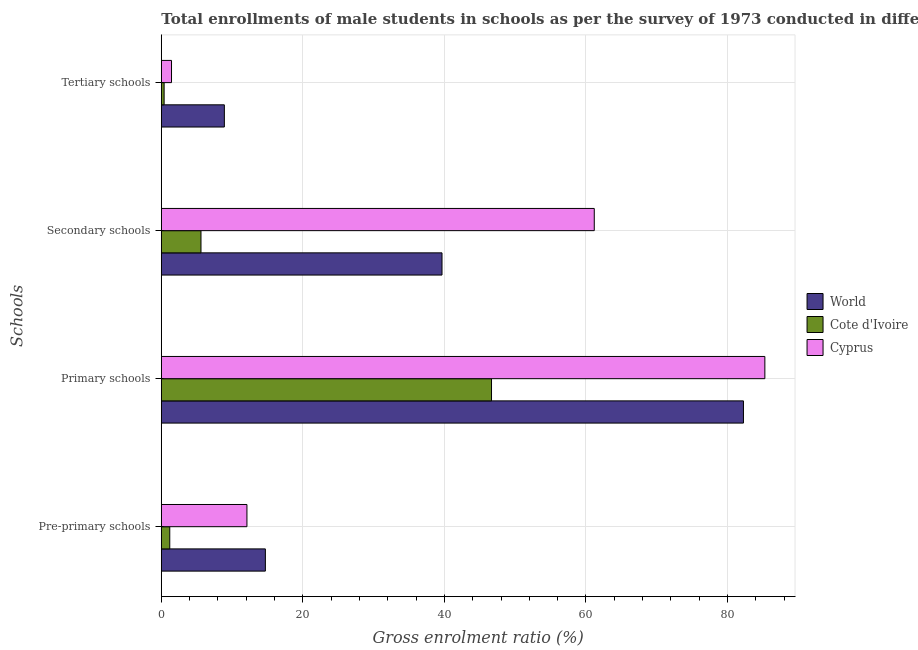Are the number of bars on each tick of the Y-axis equal?
Offer a terse response. Yes. What is the label of the 3rd group of bars from the top?
Your answer should be compact. Primary schools. What is the gross enrolment ratio(male) in pre-primary schools in World?
Ensure brevity in your answer.  14.7. Across all countries, what is the maximum gross enrolment ratio(male) in secondary schools?
Ensure brevity in your answer.  61.18. Across all countries, what is the minimum gross enrolment ratio(male) in tertiary schools?
Provide a succinct answer. 0.4. In which country was the gross enrolment ratio(male) in primary schools maximum?
Keep it short and to the point. Cyprus. In which country was the gross enrolment ratio(male) in pre-primary schools minimum?
Give a very brief answer. Cote d'Ivoire. What is the total gross enrolment ratio(male) in pre-primary schools in the graph?
Make the answer very short. 28. What is the difference between the gross enrolment ratio(male) in pre-primary schools in Cyprus and that in Cote d'Ivoire?
Give a very brief answer. 10.91. What is the difference between the gross enrolment ratio(male) in secondary schools in Cyprus and the gross enrolment ratio(male) in tertiary schools in World?
Your response must be concise. 52.27. What is the average gross enrolment ratio(male) in tertiary schools per country?
Your answer should be very brief. 3.58. What is the difference between the gross enrolment ratio(male) in secondary schools and gross enrolment ratio(male) in tertiary schools in World?
Offer a terse response. 30.76. In how many countries, is the gross enrolment ratio(male) in pre-primary schools greater than 8 %?
Provide a short and direct response. 2. What is the ratio of the gross enrolment ratio(male) in secondary schools in World to that in Cote d'Ivoire?
Ensure brevity in your answer.  7.08. Is the difference between the gross enrolment ratio(male) in pre-primary schools in Cote d'Ivoire and Cyprus greater than the difference between the gross enrolment ratio(male) in primary schools in Cote d'Ivoire and Cyprus?
Provide a succinct answer. Yes. What is the difference between the highest and the second highest gross enrolment ratio(male) in tertiary schools?
Make the answer very short. 7.47. What is the difference between the highest and the lowest gross enrolment ratio(male) in tertiary schools?
Offer a very short reply. 8.51. In how many countries, is the gross enrolment ratio(male) in secondary schools greater than the average gross enrolment ratio(male) in secondary schools taken over all countries?
Your answer should be very brief. 2. Is it the case that in every country, the sum of the gross enrolment ratio(male) in pre-primary schools and gross enrolment ratio(male) in secondary schools is greater than the sum of gross enrolment ratio(male) in primary schools and gross enrolment ratio(male) in tertiary schools?
Give a very brief answer. No. What does the 2nd bar from the top in Primary schools represents?
Offer a very short reply. Cote d'Ivoire. What does the 3rd bar from the bottom in Primary schools represents?
Provide a succinct answer. Cyprus. How many countries are there in the graph?
Ensure brevity in your answer.  3. How are the legend labels stacked?
Give a very brief answer. Vertical. What is the title of the graph?
Ensure brevity in your answer.  Total enrollments of male students in schools as per the survey of 1973 conducted in different countries. What is the label or title of the X-axis?
Provide a short and direct response. Gross enrolment ratio (%). What is the label or title of the Y-axis?
Ensure brevity in your answer.  Schools. What is the Gross enrolment ratio (%) of World in Pre-primary schools?
Keep it short and to the point. 14.7. What is the Gross enrolment ratio (%) in Cote d'Ivoire in Pre-primary schools?
Keep it short and to the point. 1.19. What is the Gross enrolment ratio (%) in Cyprus in Pre-primary schools?
Give a very brief answer. 12.1. What is the Gross enrolment ratio (%) in World in Primary schools?
Offer a terse response. 82.26. What is the Gross enrolment ratio (%) in Cote d'Ivoire in Primary schools?
Make the answer very short. 46.66. What is the Gross enrolment ratio (%) in Cyprus in Primary schools?
Make the answer very short. 85.28. What is the Gross enrolment ratio (%) in World in Secondary schools?
Provide a succinct answer. 39.66. What is the Gross enrolment ratio (%) in Cote d'Ivoire in Secondary schools?
Give a very brief answer. 5.61. What is the Gross enrolment ratio (%) in Cyprus in Secondary schools?
Keep it short and to the point. 61.18. What is the Gross enrolment ratio (%) in World in Tertiary schools?
Make the answer very short. 8.91. What is the Gross enrolment ratio (%) of Cote d'Ivoire in Tertiary schools?
Ensure brevity in your answer.  0.4. What is the Gross enrolment ratio (%) in Cyprus in Tertiary schools?
Make the answer very short. 1.44. Across all Schools, what is the maximum Gross enrolment ratio (%) of World?
Offer a very short reply. 82.26. Across all Schools, what is the maximum Gross enrolment ratio (%) in Cote d'Ivoire?
Give a very brief answer. 46.66. Across all Schools, what is the maximum Gross enrolment ratio (%) of Cyprus?
Provide a succinct answer. 85.28. Across all Schools, what is the minimum Gross enrolment ratio (%) in World?
Keep it short and to the point. 8.91. Across all Schools, what is the minimum Gross enrolment ratio (%) of Cote d'Ivoire?
Your answer should be very brief. 0.4. Across all Schools, what is the minimum Gross enrolment ratio (%) in Cyprus?
Your answer should be very brief. 1.44. What is the total Gross enrolment ratio (%) of World in the graph?
Offer a very short reply. 145.53. What is the total Gross enrolment ratio (%) in Cote d'Ivoire in the graph?
Provide a succinct answer. 53.85. What is the total Gross enrolment ratio (%) of Cyprus in the graph?
Your answer should be very brief. 160. What is the difference between the Gross enrolment ratio (%) of World in Pre-primary schools and that in Primary schools?
Your response must be concise. -67.55. What is the difference between the Gross enrolment ratio (%) of Cote d'Ivoire in Pre-primary schools and that in Primary schools?
Offer a terse response. -45.46. What is the difference between the Gross enrolment ratio (%) of Cyprus in Pre-primary schools and that in Primary schools?
Offer a very short reply. -73.18. What is the difference between the Gross enrolment ratio (%) of World in Pre-primary schools and that in Secondary schools?
Your answer should be compact. -24.96. What is the difference between the Gross enrolment ratio (%) of Cote d'Ivoire in Pre-primary schools and that in Secondary schools?
Provide a short and direct response. -4.41. What is the difference between the Gross enrolment ratio (%) in Cyprus in Pre-primary schools and that in Secondary schools?
Keep it short and to the point. -49.08. What is the difference between the Gross enrolment ratio (%) of World in Pre-primary schools and that in Tertiary schools?
Provide a short and direct response. 5.8. What is the difference between the Gross enrolment ratio (%) in Cote d'Ivoire in Pre-primary schools and that in Tertiary schools?
Ensure brevity in your answer.  0.8. What is the difference between the Gross enrolment ratio (%) in Cyprus in Pre-primary schools and that in Tertiary schools?
Keep it short and to the point. 10.66. What is the difference between the Gross enrolment ratio (%) in World in Primary schools and that in Secondary schools?
Your answer should be compact. 42.6. What is the difference between the Gross enrolment ratio (%) in Cote d'Ivoire in Primary schools and that in Secondary schools?
Keep it short and to the point. 41.05. What is the difference between the Gross enrolment ratio (%) in Cyprus in Primary schools and that in Secondary schools?
Offer a terse response. 24.11. What is the difference between the Gross enrolment ratio (%) in World in Primary schools and that in Tertiary schools?
Provide a short and direct response. 73.35. What is the difference between the Gross enrolment ratio (%) in Cote d'Ivoire in Primary schools and that in Tertiary schools?
Ensure brevity in your answer.  46.26. What is the difference between the Gross enrolment ratio (%) in Cyprus in Primary schools and that in Tertiary schools?
Provide a succinct answer. 83.84. What is the difference between the Gross enrolment ratio (%) of World in Secondary schools and that in Tertiary schools?
Make the answer very short. 30.76. What is the difference between the Gross enrolment ratio (%) in Cote d'Ivoire in Secondary schools and that in Tertiary schools?
Provide a succinct answer. 5.21. What is the difference between the Gross enrolment ratio (%) in Cyprus in Secondary schools and that in Tertiary schools?
Your answer should be compact. 59.74. What is the difference between the Gross enrolment ratio (%) of World in Pre-primary schools and the Gross enrolment ratio (%) of Cote d'Ivoire in Primary schools?
Your answer should be compact. -31.95. What is the difference between the Gross enrolment ratio (%) in World in Pre-primary schools and the Gross enrolment ratio (%) in Cyprus in Primary schools?
Give a very brief answer. -70.58. What is the difference between the Gross enrolment ratio (%) in Cote d'Ivoire in Pre-primary schools and the Gross enrolment ratio (%) in Cyprus in Primary schools?
Offer a very short reply. -84.09. What is the difference between the Gross enrolment ratio (%) in World in Pre-primary schools and the Gross enrolment ratio (%) in Cote d'Ivoire in Secondary schools?
Make the answer very short. 9.1. What is the difference between the Gross enrolment ratio (%) of World in Pre-primary schools and the Gross enrolment ratio (%) of Cyprus in Secondary schools?
Your answer should be compact. -46.47. What is the difference between the Gross enrolment ratio (%) of Cote d'Ivoire in Pre-primary schools and the Gross enrolment ratio (%) of Cyprus in Secondary schools?
Offer a very short reply. -59.98. What is the difference between the Gross enrolment ratio (%) of World in Pre-primary schools and the Gross enrolment ratio (%) of Cote d'Ivoire in Tertiary schools?
Keep it short and to the point. 14.31. What is the difference between the Gross enrolment ratio (%) in World in Pre-primary schools and the Gross enrolment ratio (%) in Cyprus in Tertiary schools?
Provide a succinct answer. 13.26. What is the difference between the Gross enrolment ratio (%) of Cote d'Ivoire in Pre-primary schools and the Gross enrolment ratio (%) of Cyprus in Tertiary schools?
Keep it short and to the point. -0.25. What is the difference between the Gross enrolment ratio (%) of World in Primary schools and the Gross enrolment ratio (%) of Cote d'Ivoire in Secondary schools?
Ensure brevity in your answer.  76.65. What is the difference between the Gross enrolment ratio (%) of World in Primary schools and the Gross enrolment ratio (%) of Cyprus in Secondary schools?
Make the answer very short. 21.08. What is the difference between the Gross enrolment ratio (%) in Cote d'Ivoire in Primary schools and the Gross enrolment ratio (%) in Cyprus in Secondary schools?
Give a very brief answer. -14.52. What is the difference between the Gross enrolment ratio (%) of World in Primary schools and the Gross enrolment ratio (%) of Cote d'Ivoire in Tertiary schools?
Provide a succinct answer. 81.86. What is the difference between the Gross enrolment ratio (%) in World in Primary schools and the Gross enrolment ratio (%) in Cyprus in Tertiary schools?
Offer a very short reply. 80.82. What is the difference between the Gross enrolment ratio (%) in Cote d'Ivoire in Primary schools and the Gross enrolment ratio (%) in Cyprus in Tertiary schools?
Make the answer very short. 45.22. What is the difference between the Gross enrolment ratio (%) of World in Secondary schools and the Gross enrolment ratio (%) of Cote d'Ivoire in Tertiary schools?
Make the answer very short. 39.26. What is the difference between the Gross enrolment ratio (%) of World in Secondary schools and the Gross enrolment ratio (%) of Cyprus in Tertiary schools?
Your answer should be very brief. 38.22. What is the difference between the Gross enrolment ratio (%) in Cote d'Ivoire in Secondary schools and the Gross enrolment ratio (%) in Cyprus in Tertiary schools?
Give a very brief answer. 4.17. What is the average Gross enrolment ratio (%) in World per Schools?
Make the answer very short. 36.38. What is the average Gross enrolment ratio (%) of Cote d'Ivoire per Schools?
Offer a very short reply. 13.46. What is the average Gross enrolment ratio (%) of Cyprus per Schools?
Ensure brevity in your answer.  40. What is the difference between the Gross enrolment ratio (%) in World and Gross enrolment ratio (%) in Cote d'Ivoire in Pre-primary schools?
Offer a terse response. 13.51. What is the difference between the Gross enrolment ratio (%) in World and Gross enrolment ratio (%) in Cyprus in Pre-primary schools?
Provide a succinct answer. 2.6. What is the difference between the Gross enrolment ratio (%) in Cote d'Ivoire and Gross enrolment ratio (%) in Cyprus in Pre-primary schools?
Keep it short and to the point. -10.91. What is the difference between the Gross enrolment ratio (%) in World and Gross enrolment ratio (%) in Cote d'Ivoire in Primary schools?
Ensure brevity in your answer.  35.6. What is the difference between the Gross enrolment ratio (%) in World and Gross enrolment ratio (%) in Cyprus in Primary schools?
Provide a short and direct response. -3.02. What is the difference between the Gross enrolment ratio (%) in Cote d'Ivoire and Gross enrolment ratio (%) in Cyprus in Primary schools?
Offer a very short reply. -38.62. What is the difference between the Gross enrolment ratio (%) of World and Gross enrolment ratio (%) of Cote d'Ivoire in Secondary schools?
Provide a short and direct response. 34.06. What is the difference between the Gross enrolment ratio (%) of World and Gross enrolment ratio (%) of Cyprus in Secondary schools?
Offer a very short reply. -21.51. What is the difference between the Gross enrolment ratio (%) in Cote d'Ivoire and Gross enrolment ratio (%) in Cyprus in Secondary schools?
Make the answer very short. -55.57. What is the difference between the Gross enrolment ratio (%) of World and Gross enrolment ratio (%) of Cote d'Ivoire in Tertiary schools?
Offer a terse response. 8.51. What is the difference between the Gross enrolment ratio (%) in World and Gross enrolment ratio (%) in Cyprus in Tertiary schools?
Your answer should be very brief. 7.47. What is the difference between the Gross enrolment ratio (%) in Cote d'Ivoire and Gross enrolment ratio (%) in Cyprus in Tertiary schools?
Provide a succinct answer. -1.04. What is the ratio of the Gross enrolment ratio (%) of World in Pre-primary schools to that in Primary schools?
Provide a succinct answer. 0.18. What is the ratio of the Gross enrolment ratio (%) of Cote d'Ivoire in Pre-primary schools to that in Primary schools?
Keep it short and to the point. 0.03. What is the ratio of the Gross enrolment ratio (%) of Cyprus in Pre-primary schools to that in Primary schools?
Offer a very short reply. 0.14. What is the ratio of the Gross enrolment ratio (%) in World in Pre-primary schools to that in Secondary schools?
Offer a very short reply. 0.37. What is the ratio of the Gross enrolment ratio (%) in Cote d'Ivoire in Pre-primary schools to that in Secondary schools?
Provide a succinct answer. 0.21. What is the ratio of the Gross enrolment ratio (%) in Cyprus in Pre-primary schools to that in Secondary schools?
Provide a short and direct response. 0.2. What is the ratio of the Gross enrolment ratio (%) in World in Pre-primary schools to that in Tertiary schools?
Your response must be concise. 1.65. What is the ratio of the Gross enrolment ratio (%) in Cote d'Ivoire in Pre-primary schools to that in Tertiary schools?
Make the answer very short. 3. What is the ratio of the Gross enrolment ratio (%) in Cyprus in Pre-primary schools to that in Tertiary schools?
Ensure brevity in your answer.  8.4. What is the ratio of the Gross enrolment ratio (%) in World in Primary schools to that in Secondary schools?
Ensure brevity in your answer.  2.07. What is the ratio of the Gross enrolment ratio (%) of Cote d'Ivoire in Primary schools to that in Secondary schools?
Provide a succinct answer. 8.32. What is the ratio of the Gross enrolment ratio (%) of Cyprus in Primary schools to that in Secondary schools?
Offer a terse response. 1.39. What is the ratio of the Gross enrolment ratio (%) in World in Primary schools to that in Tertiary schools?
Offer a very short reply. 9.23. What is the ratio of the Gross enrolment ratio (%) in Cote d'Ivoire in Primary schools to that in Tertiary schools?
Offer a very short reply. 117.39. What is the ratio of the Gross enrolment ratio (%) of Cyprus in Primary schools to that in Tertiary schools?
Your answer should be compact. 59.19. What is the ratio of the Gross enrolment ratio (%) of World in Secondary schools to that in Tertiary schools?
Provide a short and direct response. 4.45. What is the ratio of the Gross enrolment ratio (%) of Cote d'Ivoire in Secondary schools to that in Tertiary schools?
Provide a short and direct response. 14.1. What is the ratio of the Gross enrolment ratio (%) of Cyprus in Secondary schools to that in Tertiary schools?
Make the answer very short. 42.46. What is the difference between the highest and the second highest Gross enrolment ratio (%) of World?
Give a very brief answer. 42.6. What is the difference between the highest and the second highest Gross enrolment ratio (%) in Cote d'Ivoire?
Give a very brief answer. 41.05. What is the difference between the highest and the second highest Gross enrolment ratio (%) of Cyprus?
Make the answer very short. 24.11. What is the difference between the highest and the lowest Gross enrolment ratio (%) of World?
Ensure brevity in your answer.  73.35. What is the difference between the highest and the lowest Gross enrolment ratio (%) of Cote d'Ivoire?
Make the answer very short. 46.26. What is the difference between the highest and the lowest Gross enrolment ratio (%) of Cyprus?
Provide a succinct answer. 83.84. 